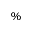<formula> <loc_0><loc_0><loc_500><loc_500>\%</formula> 